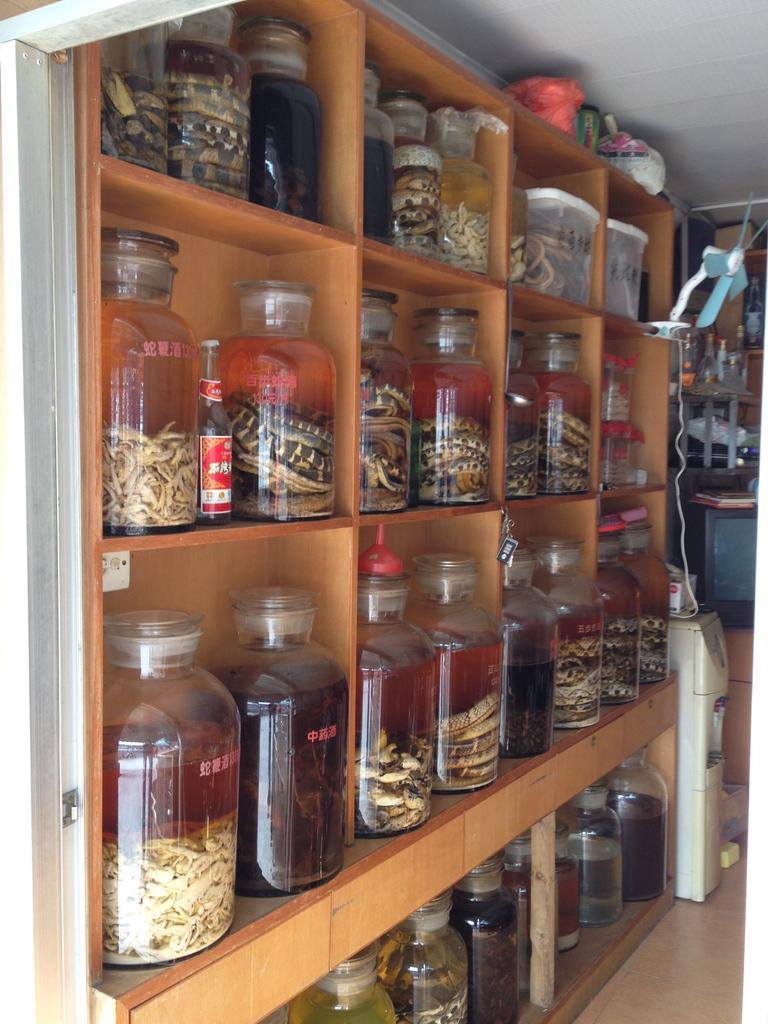Could you give a brief overview of what you see in this image? Here we can see a rack, full of containers which are full of something and at the right side we can see a water purifier and above that there is a fan placed 